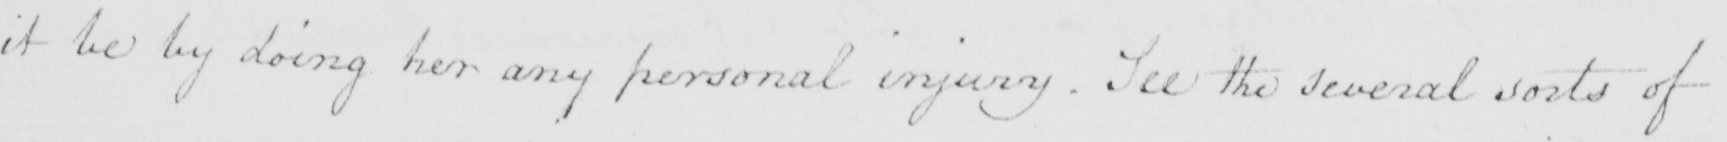What does this handwritten line say? it be by doing her any personal injury . See the several sorts of 